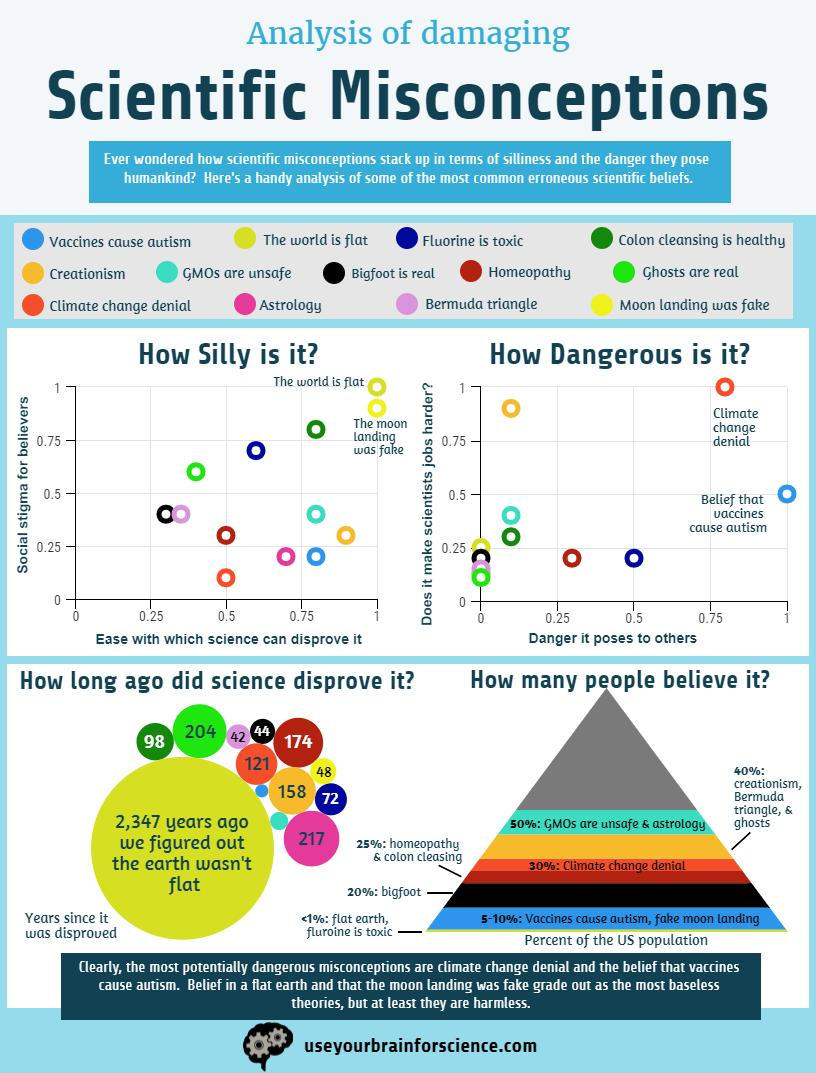List a handful of essential elements in this visual. The scientific misconception that is ranked lowest in social stigma and is not easily disproved is that Bigfoot is real. Colon cleansing is not healthy and ranks third in scientific misconceptions with the highest social stigma. This misconception is widely believed despite being disproven by scientific evidence. Of the scientific misconceptions, the least threatening ones are those that number 4. Based on the data, we found that approximately 8 out of 10 scientific misconceptions have a low risk of causing harm to others, with a rating below 0.5 on the scale. According to a study, fluorine is the third most dangerous scientific misconception in terms of the harm it can pose to individuals who believe it. This toxic element can lead to serious health problems when ingested or inhaled, making it crucial to educate the public about its dangers. 